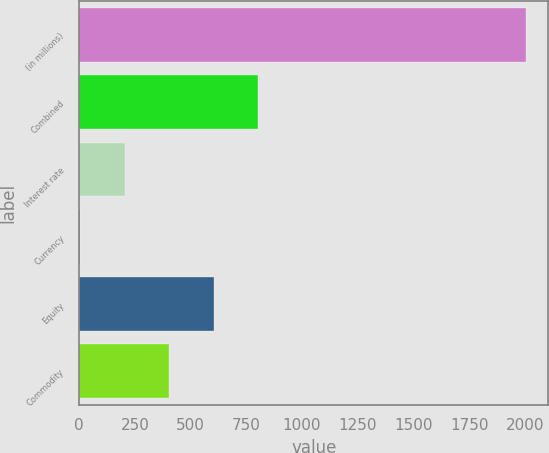Convert chart. <chart><loc_0><loc_0><loc_500><loc_500><bar_chart><fcel>(in millions)<fcel>Combined<fcel>Interest rate<fcel>Currency<fcel>Equity<fcel>Commodity<nl><fcel>2005<fcel>803.8<fcel>203.2<fcel>3<fcel>603.6<fcel>403.4<nl></chart> 